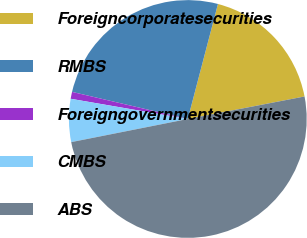Convert chart to OTSL. <chart><loc_0><loc_0><loc_500><loc_500><pie_chart><fcel>Foreigncorporatesecurities<fcel>RMBS<fcel>Foreigngovernmentsecurities<fcel>CMBS<fcel>ABS<nl><fcel>17.89%<fcel>25.42%<fcel>0.94%<fcel>5.84%<fcel>49.91%<nl></chart> 